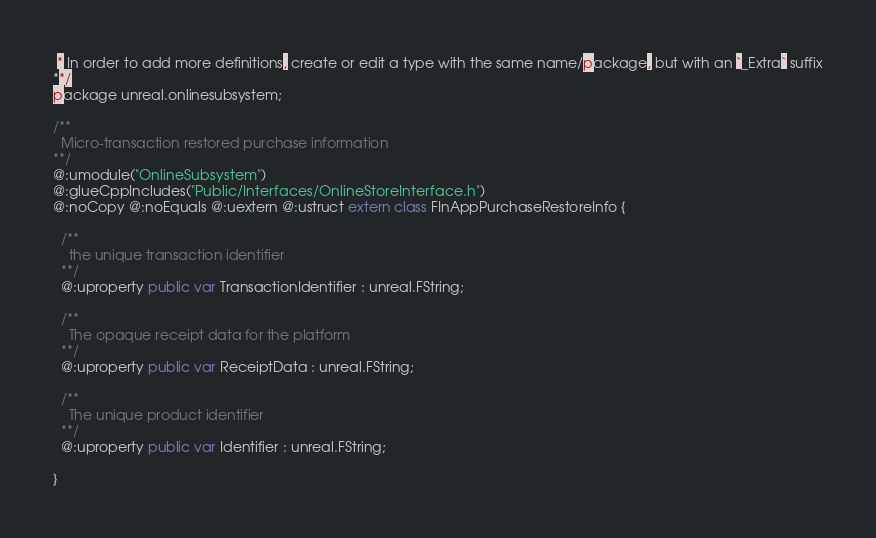<code> <loc_0><loc_0><loc_500><loc_500><_Haxe_> * In order to add more definitions, create or edit a type with the same name/package, but with an `_Extra` suffix
**/
package unreal.onlinesubsystem;

/**
  Micro-transaction restored purchase information
**/
@:umodule("OnlineSubsystem")
@:glueCppIncludes("Public/Interfaces/OnlineStoreInterface.h")
@:noCopy @:noEquals @:uextern @:ustruct extern class FInAppPurchaseRestoreInfo {
  
  /**
    the unique transaction identifier
  **/
  @:uproperty public var TransactionIdentifier : unreal.FString;
  
  /**
    The opaque receipt data for the platform
  **/
  @:uproperty public var ReceiptData : unreal.FString;
  
  /**
    The unique product identifier
  **/
  @:uproperty public var Identifier : unreal.FString;
  
}
</code> 